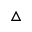<formula> <loc_0><loc_0><loc_500><loc_500>\triangle</formula> 